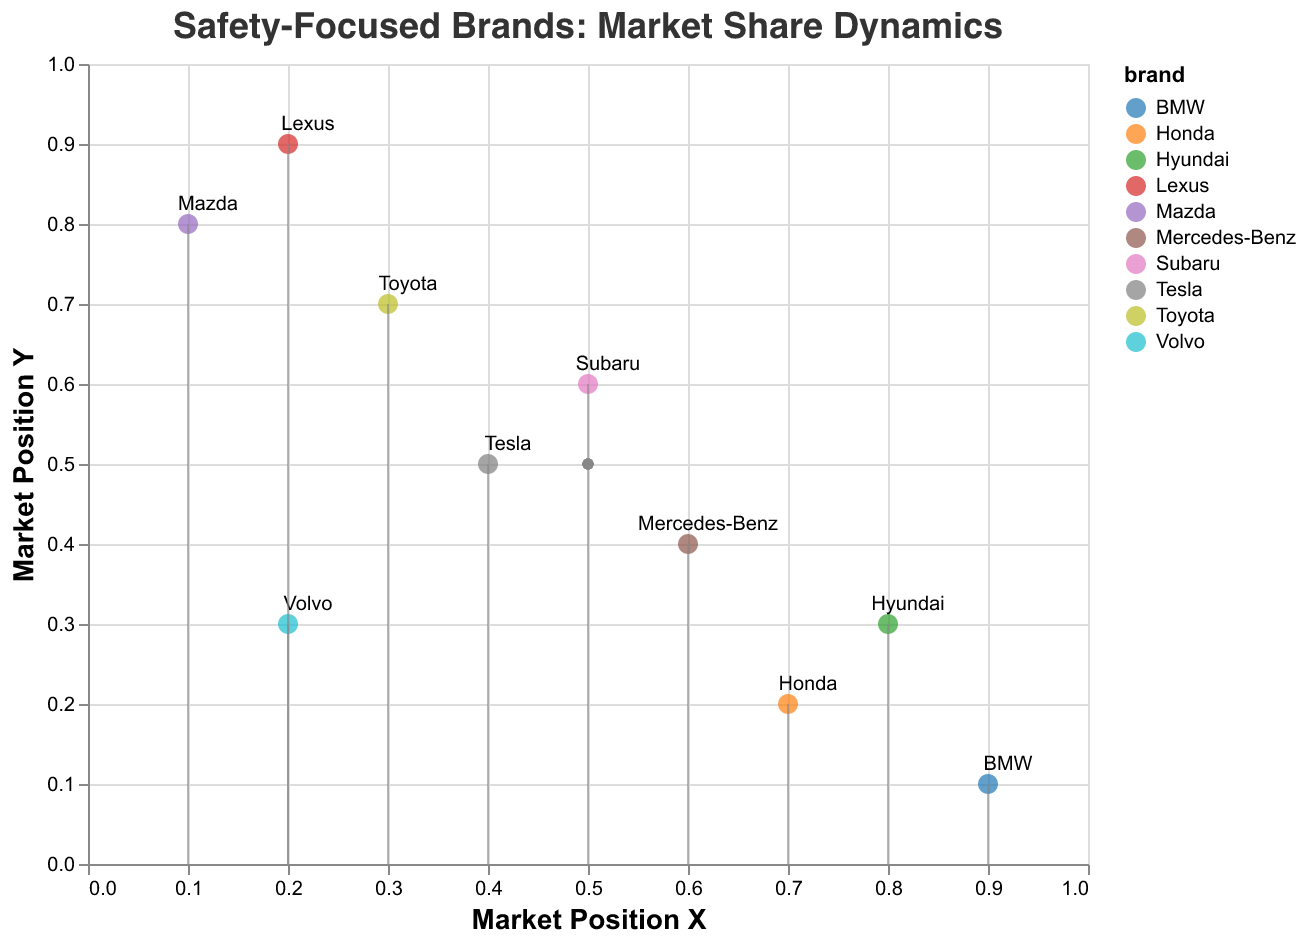What does the title of the figure indicate? The title of the figure indicates that it is about the competitive landscape analysis of brands focused on safety, specifically their market share dynamics.
Answer: Safety-Focused Brands: Market Share Dynamics How many brands are represented in the figure? There are 10 data points, each representing a different brand, so there are 10 brands in total.
Answer: 10 Which brand has the greatest horizontal movement to the right? To determine this, observe the horizontal components (u) of the vectors. Lexus has the highest positive value in the horizontal direction (u = 0.06).
Answer: Lexus Which brand shows a potential decline in market position based on the quiver plot? Brands that show negative vertical movement (v < 0) indicate a decline in market position. "Mercedes-Benz", "Subaru", "Mazda", and "Lexus" all have negative vertical movements.
Answer: Mercedes-Benz, Subaru, Mazda, Lexus Which brand shows the most significant positive vertical movement? This can be observed by looking at the brand with the highest positive value for the vertical component (v). Hyundai has the highest positive vertical value (v = 0.07).
Answer: Hyundai Are there any brands that have both negative horizontal and vertical movement? Check for brands where both u and v are negative. "Mercedes-Benz" and "Subaru" both have negative values for u and v.
Answer: Mercedes-Benz, Subaru What is the market position of Tesla? Refer to the axis values where Tesla is positioned. Tesla is located at (0.4, 0.5) in the market position.
Answer: (0.4, 0.5) Which brands are positioned close to the bottom left corner? Look for brands with low x and y values. Volvo and BMW are positioned close to the bottom left corner with respective coordinates (0.2, 0.3) and (0.9, 0.1).
Answer: Volvo, BMW Which brand has the longest vector? Calculating the vector magnitude, Lexus has the longest vector with a magnitude sqrt(0.06^2 + (-0.03)^2) = 0.067.
Answer: Lexus 